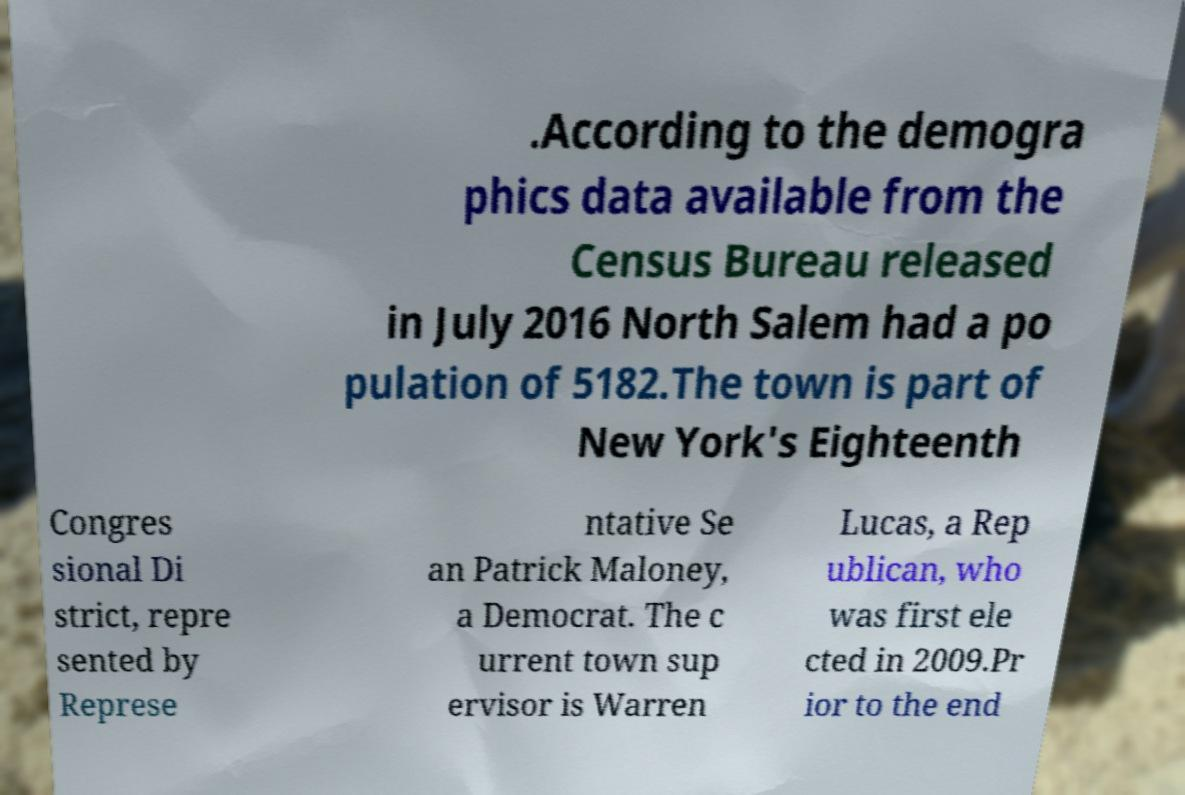Please read and relay the text visible in this image. What does it say? .According to the demogra phics data available from the Census Bureau released in July 2016 North Salem had a po pulation of 5182.The town is part of New York's Eighteenth Congres sional Di strict, repre sented by Represe ntative Se an Patrick Maloney, a Democrat. The c urrent town sup ervisor is Warren Lucas, a Rep ublican, who was first ele cted in 2009.Pr ior to the end 